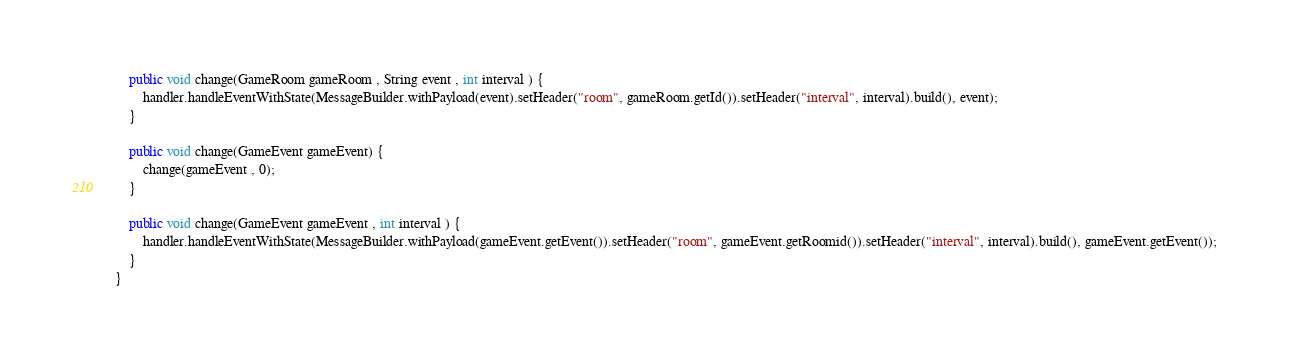<code> <loc_0><loc_0><loc_500><loc_500><_Java_>	public void change(GameRoom gameRoom , String event , int interval ) { 
		handler.handleEventWithState(MessageBuilder.withPayload(event).setHeader("room", gameRoom.getId()).setHeader("interval", interval).build(), event);
	}
	
	public void change(GameEvent gameEvent) { 
		change(gameEvent , 0); 
	} 
	
	public void change(GameEvent gameEvent , int interval ) { 
		handler.handleEventWithState(MessageBuilder.withPayload(gameEvent.getEvent()).setHeader("room", gameEvent.getRoomid()).setHeader("interval", interval).build(), gameEvent.getEvent()); 
	} 
}
</code> 